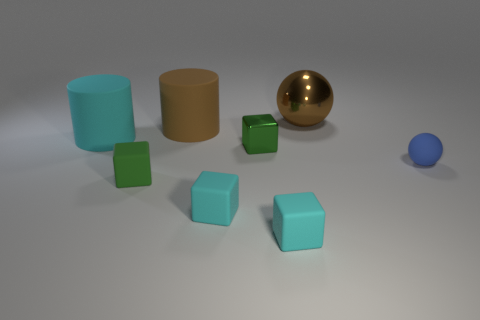What materials do the objects in the image seem to be made of? The objects in the image appear to be made of various materials. The shiny gold sphere looks metallic, suggesting it might be made of metal or a reflective plastic. The blue sphere and the green cubes have a matte finish, indicative of a rubber-like material. The cyan and brown cylinders have a slight sheen, which could suggest a plastic material. 